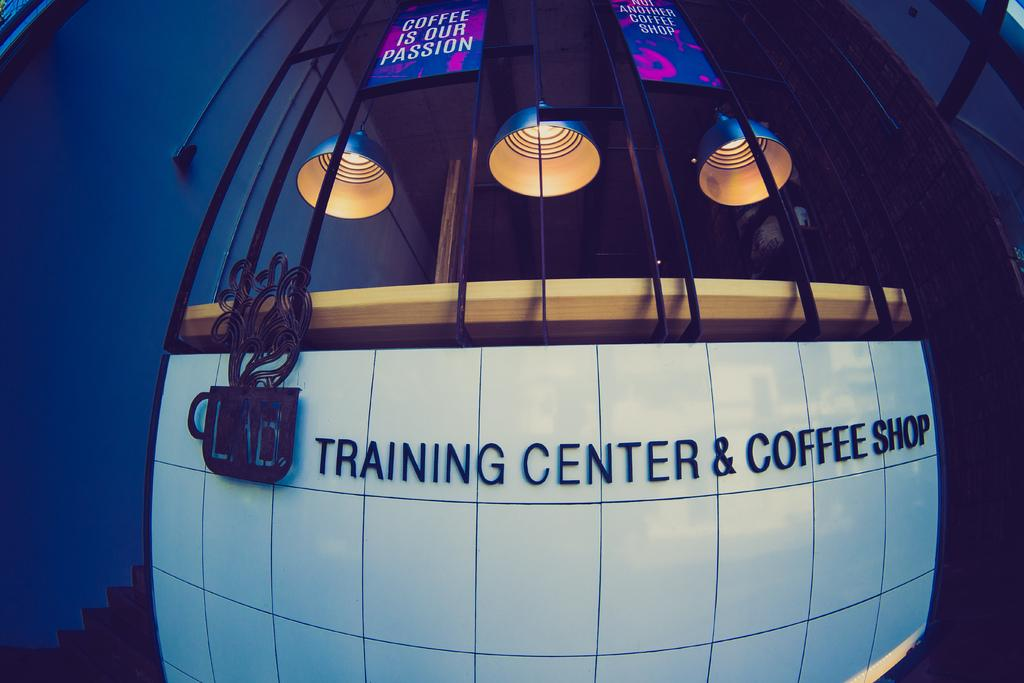<image>
Give a short and clear explanation of the subsequent image. A sign on a wall says LAB Training Center & Coffee Shop. 